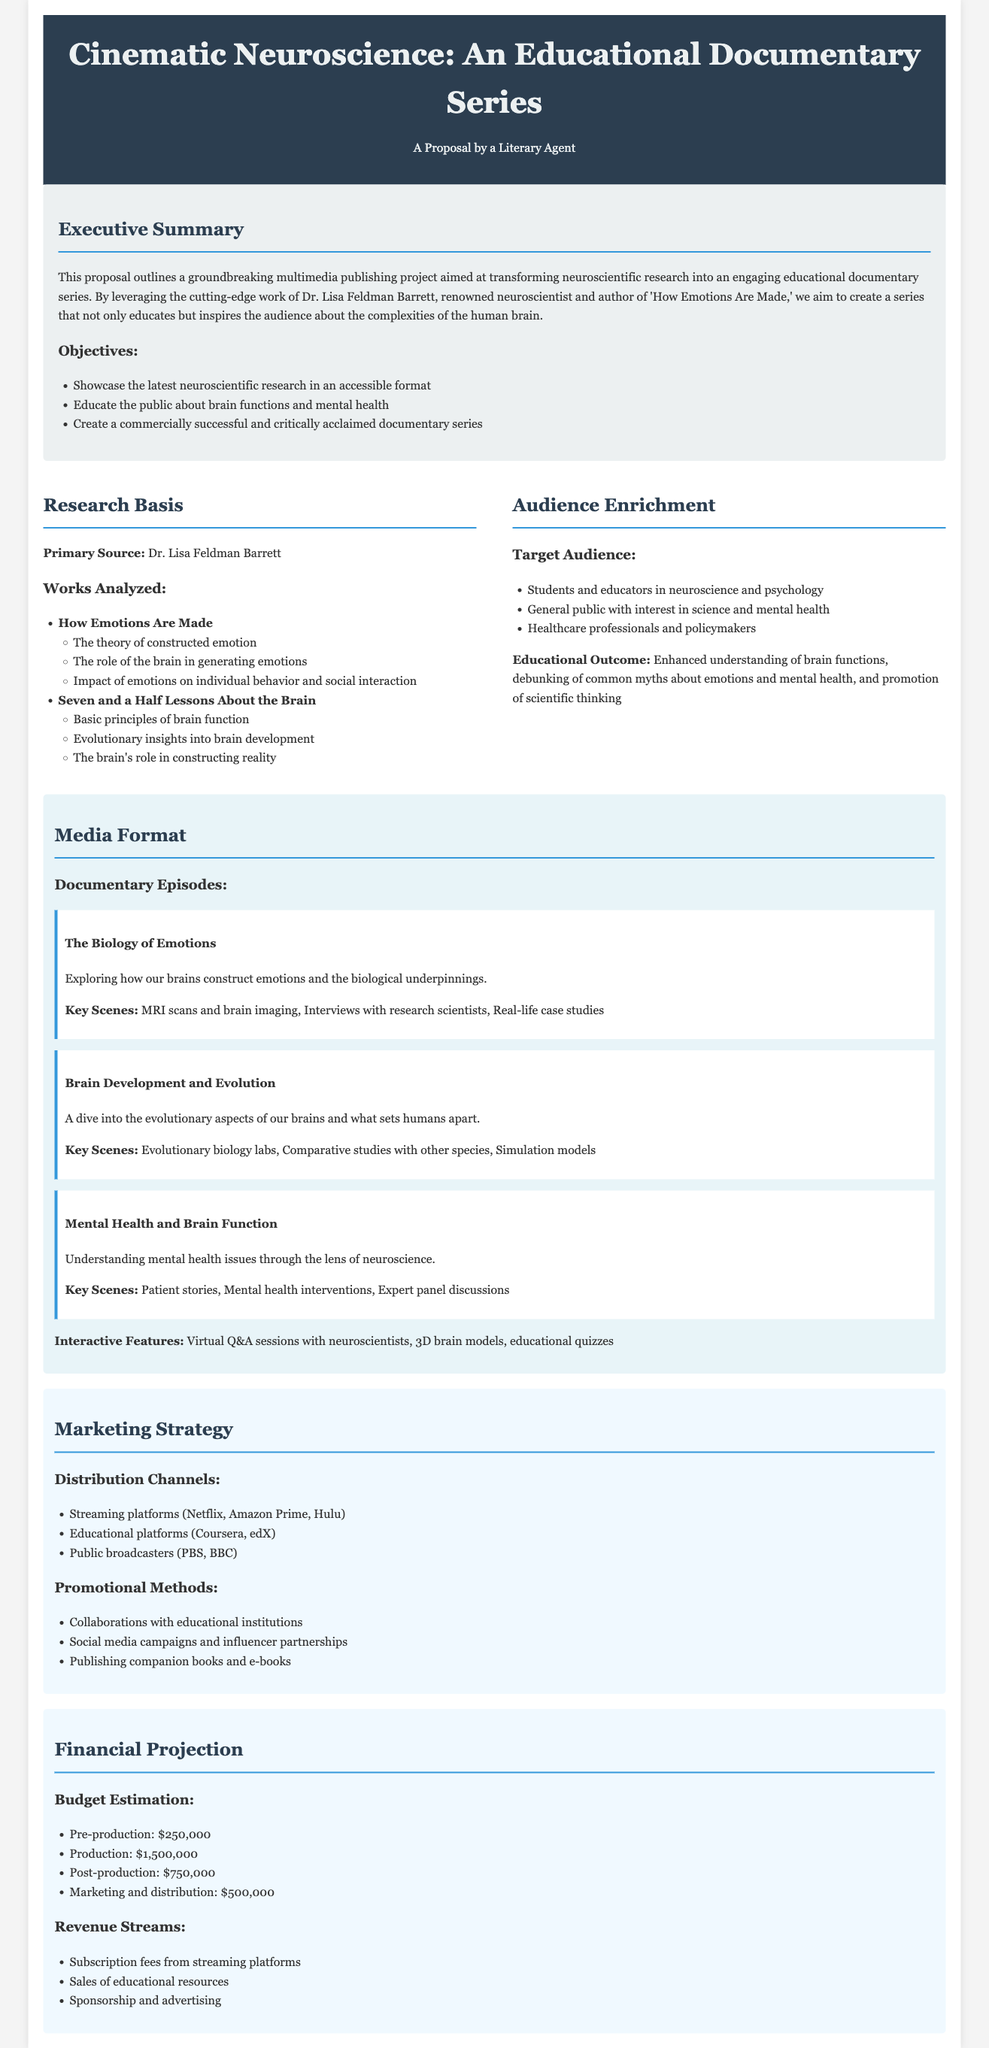What is the title of the proposal? The title of the proposal is provided in the header section of the document.
Answer: Cinematic Neuroscience: An Educational Documentary Series Who is the primary source of the research featured in the proposal? The proposal specifies Dr. Lisa Feldman Barrett as the primary source of the research.
Answer: Dr. Lisa Feldman Barrett What is the budget estimation for pre-production? The document lists the budget estimation for pre-production under the Financial Projection section.
Answer: $250,000 What is one of the key scenes in the episode "The Biology of Emotions"? The proposal includes specific key scenes for each documentary episode.
Answer: MRI scans and brain imaging Which streaming platforms are mentioned as distribution channels? The marketing strategy section outlines various distribution channels, including specific platforms.
Answer: Netflix, Amazon Prime, Hulu What is the educational outcome of the series? The proposal highlights an educational outcome related to audience understanding in the Audience Enrichment section.
Answer: Enhanced understanding of brain functions What type of campaign is mentioned in the promotional methods? The document discusses different promotional methods in the Marketing Strategy section.
Answer: Social media campaigns How many documentary episodes are listed in the media format? The number of episodes is indicated in the Media Format section of the proposal.
Answer: Three 